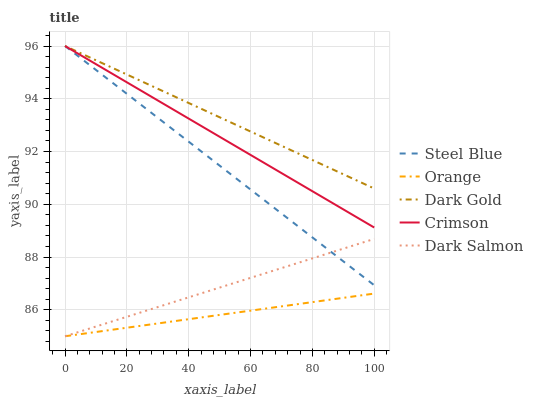Does Orange have the minimum area under the curve?
Answer yes or no. Yes. Does Dark Gold have the maximum area under the curve?
Answer yes or no. Yes. Does Crimson have the minimum area under the curve?
Answer yes or no. No. Does Crimson have the maximum area under the curve?
Answer yes or no. No. Is Dark Gold the smoothest?
Answer yes or no. Yes. Is Crimson the roughest?
Answer yes or no. Yes. Is Dark Salmon the smoothest?
Answer yes or no. No. Is Dark Salmon the roughest?
Answer yes or no. No. Does Orange have the lowest value?
Answer yes or no. Yes. Does Crimson have the lowest value?
Answer yes or no. No. Does Dark Gold have the highest value?
Answer yes or no. Yes. Does Dark Salmon have the highest value?
Answer yes or no. No. Is Orange less than Dark Gold?
Answer yes or no. Yes. Is Dark Gold greater than Orange?
Answer yes or no. Yes. Does Orange intersect Dark Salmon?
Answer yes or no. Yes. Is Orange less than Dark Salmon?
Answer yes or no. No. Is Orange greater than Dark Salmon?
Answer yes or no. No. Does Orange intersect Dark Gold?
Answer yes or no. No. 